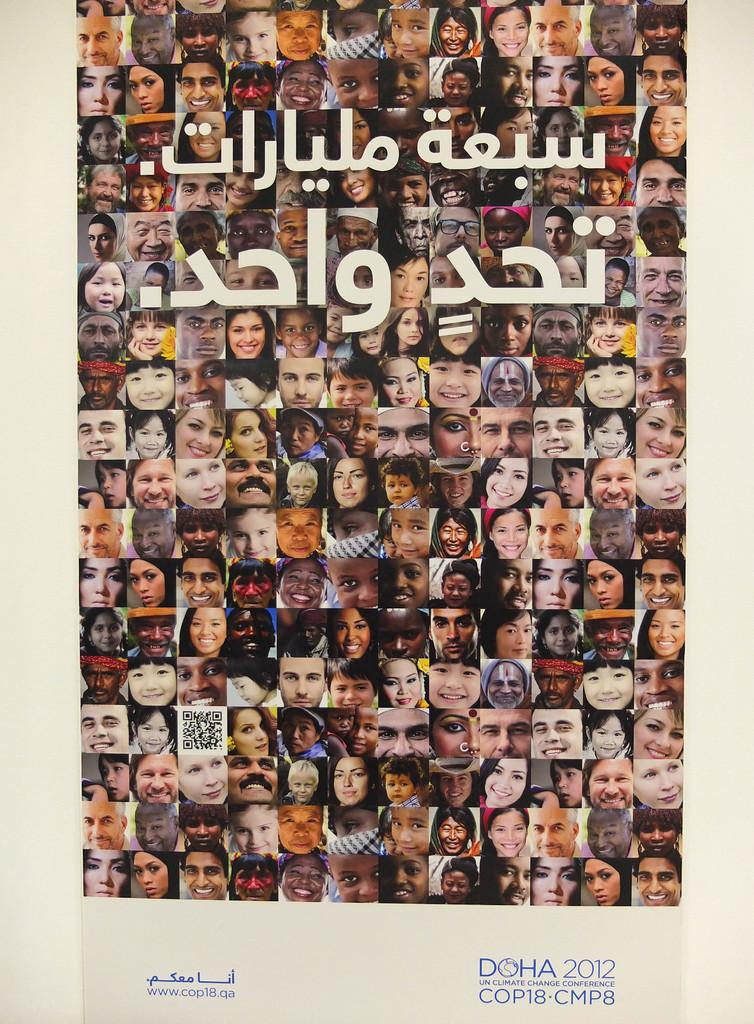What is present in the image? There is a poster in the image. What can be seen on the poster? The poster contains many photos of people. What type of vest is the pet wearing in the image? There is no pet or vest present in the image; the poster contains photos of people. 